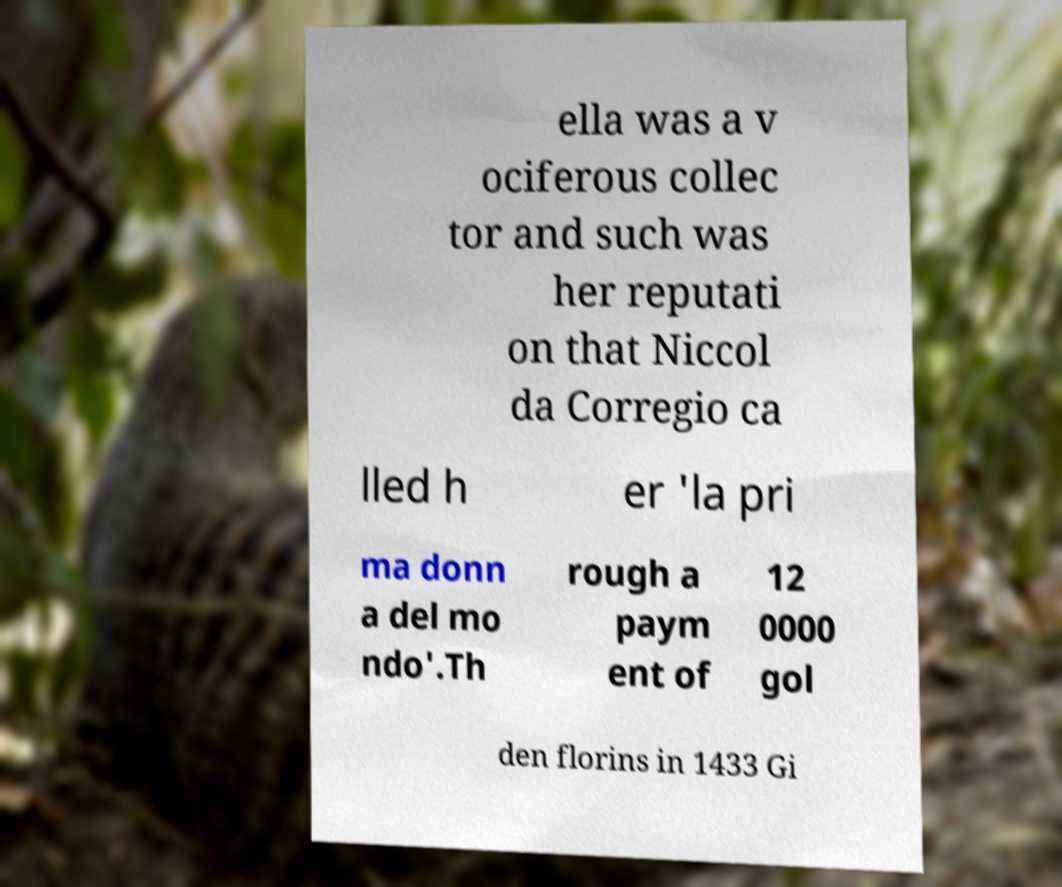Can you read and provide the text displayed in the image?This photo seems to have some interesting text. Can you extract and type it out for me? ella was a v ociferous collec tor and such was her reputati on that Niccol da Corregio ca lled h er 'la pri ma donn a del mo ndo'.Th rough a paym ent of 12 0000 gol den florins in 1433 Gi 